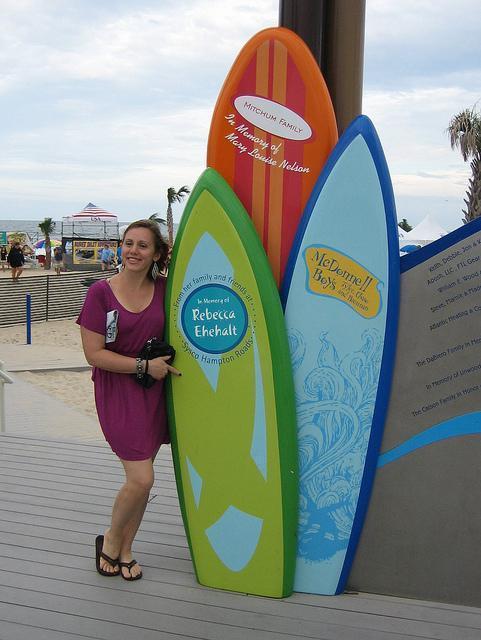How many surfboards are there?
Give a very brief answer. 3. How many surfboards can be seen?
Give a very brief answer. 3. 